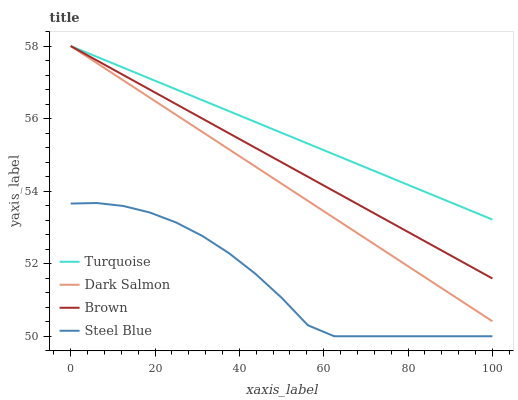Does Steel Blue have the minimum area under the curve?
Answer yes or no. Yes. Does Turquoise have the maximum area under the curve?
Answer yes or no. Yes. Does Dark Salmon have the minimum area under the curve?
Answer yes or no. No. Does Dark Salmon have the maximum area under the curve?
Answer yes or no. No. Is Dark Salmon the smoothest?
Answer yes or no. Yes. Is Steel Blue the roughest?
Answer yes or no. Yes. Is Turquoise the smoothest?
Answer yes or no. No. Is Turquoise the roughest?
Answer yes or no. No. Does Steel Blue have the lowest value?
Answer yes or no. Yes. Does Dark Salmon have the lowest value?
Answer yes or no. No. Does Dark Salmon have the highest value?
Answer yes or no. Yes. Does Steel Blue have the highest value?
Answer yes or no. No. Is Steel Blue less than Dark Salmon?
Answer yes or no. Yes. Is Turquoise greater than Steel Blue?
Answer yes or no. Yes. Does Dark Salmon intersect Turquoise?
Answer yes or no. Yes. Is Dark Salmon less than Turquoise?
Answer yes or no. No. Is Dark Salmon greater than Turquoise?
Answer yes or no. No. Does Steel Blue intersect Dark Salmon?
Answer yes or no. No. 